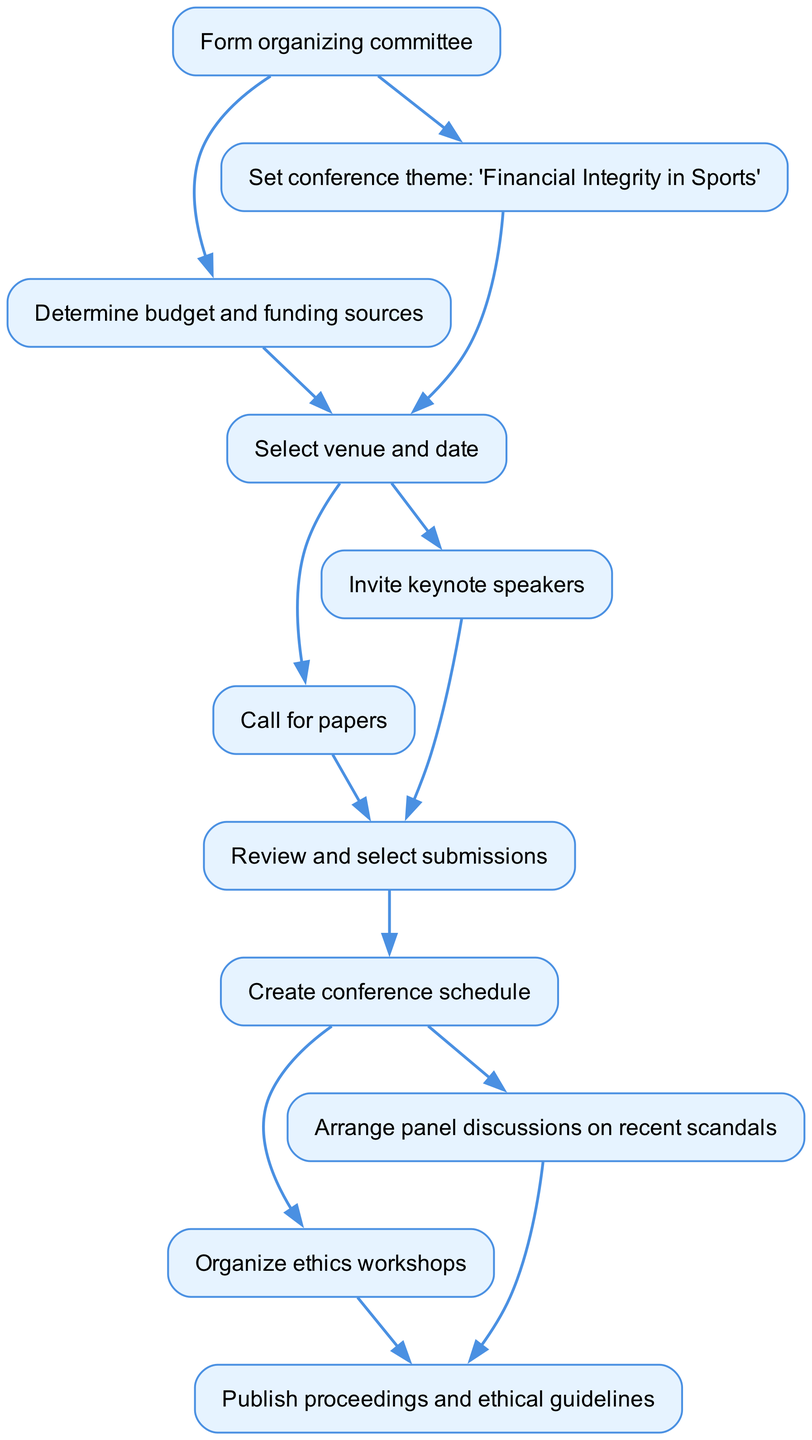What is the first step in the workflow? The first step is to "Form organizing committee," as indicated by the starting point in the diagram. This is the first node listed in the flow chart.
Answer: Form organizing committee How many total nodes are in the diagram? Counting each distinct box in the flow chart, there are 11 nodes represented, each corresponding to a specific step in the workflow.
Answer: 11 What theme is set for the conference? Referring to node 2 in the diagram, the conference theme is "Financial Integrity in Sports," which is explicitly stated.
Answer: Financial Integrity in Sports Which two tasks can occur after selecting the venue and date? After selecting the venue and date (node 4), the next tasks are to "Invite keynote speakers" (node 5) and "Call for papers" (node 6), as shown by the outgoing edges from node 4.
Answer: Invite keynote speakers, Call for papers What is the terminal task in the workflow? The final task in the workflow, indicated by the last node, is to "Publish proceedings and ethical guidelines," which concludes the process outlined in the flow chart.
Answer: Publish proceedings and ethical guidelines How many pathways are there from the "Review and select submissions" step? From the "Review and select submissions" step (node 7), there are two pathways, leading to either "Create conference schedule" (node 8) leading to further nodes or tasks indicated next.
Answer: 2 What is the connection between "Arrange panel discussions on recent scandals" and "Organize ethics workshops"? Both "Arrange panel discussions on recent scandals" (node 9) and "Organize ethics workshops" (node 10) follow the "Create conference schedule" (node 8). They are both next steps in the workflow stemming from the same previous task.
Answer: They follow the same step Which step comes directly after determining budget? The step that comes directly after "Determine budget and funding sources" (node 3) is "Select venue and date" (node 4), as shown by the connection leading to node 4.
Answer: Select venue and date What do you need to do after inviting keynote speakers and calling for papers? After both "Invite keynote speakers" (node 5) and "Call for papers" (node 6), the next step is to "Review and select submissions" (node 7), indicating that those tasks are succeeded by this common step.
Answer: Review and select submissions 